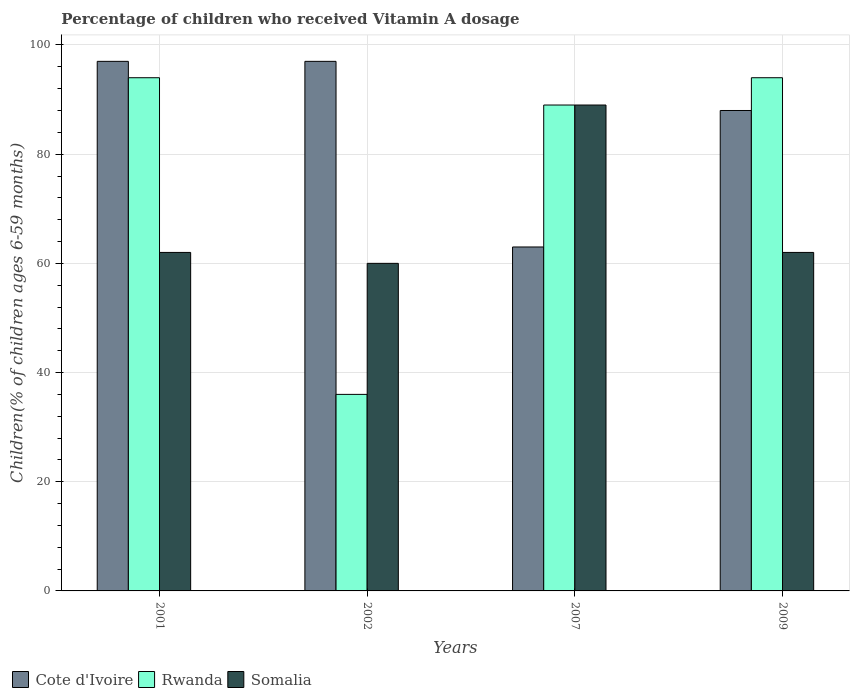How many different coloured bars are there?
Provide a short and direct response. 3. How many groups of bars are there?
Provide a short and direct response. 4. Are the number of bars per tick equal to the number of legend labels?
Offer a terse response. Yes. Are the number of bars on each tick of the X-axis equal?
Ensure brevity in your answer.  Yes. How many bars are there on the 2nd tick from the right?
Your answer should be very brief. 3. What is the label of the 1st group of bars from the left?
Provide a succinct answer. 2001. What is the percentage of children who received Vitamin A dosage in Cote d'Ivoire in 2001?
Offer a very short reply. 97. Across all years, what is the maximum percentage of children who received Vitamin A dosage in Rwanda?
Offer a very short reply. 94. In which year was the percentage of children who received Vitamin A dosage in Cote d'Ivoire minimum?
Give a very brief answer. 2007. What is the total percentage of children who received Vitamin A dosage in Rwanda in the graph?
Provide a succinct answer. 313. What is the difference between the percentage of children who received Vitamin A dosage in Cote d'Ivoire in 2007 and that in 2009?
Your answer should be very brief. -25. What is the difference between the percentage of children who received Vitamin A dosage in Cote d'Ivoire in 2001 and the percentage of children who received Vitamin A dosage in Somalia in 2002?
Your response must be concise. 37. What is the average percentage of children who received Vitamin A dosage in Cote d'Ivoire per year?
Ensure brevity in your answer.  86.25. In the year 2001, what is the difference between the percentage of children who received Vitamin A dosage in Somalia and percentage of children who received Vitamin A dosage in Cote d'Ivoire?
Your answer should be compact. -35. What is the ratio of the percentage of children who received Vitamin A dosage in Somalia in 2002 to that in 2007?
Your answer should be very brief. 0.67. Is the difference between the percentage of children who received Vitamin A dosage in Somalia in 2007 and 2009 greater than the difference between the percentage of children who received Vitamin A dosage in Cote d'Ivoire in 2007 and 2009?
Provide a succinct answer. Yes. What is the difference between the highest and the second highest percentage of children who received Vitamin A dosage in Cote d'Ivoire?
Provide a short and direct response. 0. Is the sum of the percentage of children who received Vitamin A dosage in Somalia in 2001 and 2002 greater than the maximum percentage of children who received Vitamin A dosage in Cote d'Ivoire across all years?
Keep it short and to the point. Yes. What does the 3rd bar from the left in 2009 represents?
Offer a very short reply. Somalia. What does the 1st bar from the right in 2007 represents?
Give a very brief answer. Somalia. Where does the legend appear in the graph?
Make the answer very short. Bottom left. How are the legend labels stacked?
Offer a very short reply. Horizontal. What is the title of the graph?
Make the answer very short. Percentage of children who received Vitamin A dosage. Does "Iraq" appear as one of the legend labels in the graph?
Your answer should be compact. No. What is the label or title of the Y-axis?
Offer a terse response. Children(% of children ages 6-59 months). What is the Children(% of children ages 6-59 months) of Cote d'Ivoire in 2001?
Offer a terse response. 97. What is the Children(% of children ages 6-59 months) of Rwanda in 2001?
Provide a short and direct response. 94. What is the Children(% of children ages 6-59 months) of Somalia in 2001?
Provide a short and direct response. 62. What is the Children(% of children ages 6-59 months) of Cote d'Ivoire in 2002?
Provide a succinct answer. 97. What is the Children(% of children ages 6-59 months) of Rwanda in 2002?
Keep it short and to the point. 36. What is the Children(% of children ages 6-59 months) of Rwanda in 2007?
Your response must be concise. 89. What is the Children(% of children ages 6-59 months) in Somalia in 2007?
Give a very brief answer. 89. What is the Children(% of children ages 6-59 months) in Rwanda in 2009?
Ensure brevity in your answer.  94. Across all years, what is the maximum Children(% of children ages 6-59 months) in Cote d'Ivoire?
Make the answer very short. 97. Across all years, what is the maximum Children(% of children ages 6-59 months) in Rwanda?
Your answer should be compact. 94. Across all years, what is the maximum Children(% of children ages 6-59 months) in Somalia?
Ensure brevity in your answer.  89. Across all years, what is the minimum Children(% of children ages 6-59 months) in Cote d'Ivoire?
Keep it short and to the point. 63. What is the total Children(% of children ages 6-59 months) in Cote d'Ivoire in the graph?
Provide a short and direct response. 345. What is the total Children(% of children ages 6-59 months) of Rwanda in the graph?
Your response must be concise. 313. What is the total Children(% of children ages 6-59 months) of Somalia in the graph?
Your answer should be compact. 273. What is the difference between the Children(% of children ages 6-59 months) in Cote d'Ivoire in 2001 and that in 2002?
Give a very brief answer. 0. What is the difference between the Children(% of children ages 6-59 months) in Cote d'Ivoire in 2001 and that in 2007?
Your answer should be very brief. 34. What is the difference between the Children(% of children ages 6-59 months) of Cote d'Ivoire in 2001 and that in 2009?
Offer a very short reply. 9. What is the difference between the Children(% of children ages 6-59 months) of Rwanda in 2001 and that in 2009?
Ensure brevity in your answer.  0. What is the difference between the Children(% of children ages 6-59 months) of Cote d'Ivoire in 2002 and that in 2007?
Offer a terse response. 34. What is the difference between the Children(% of children ages 6-59 months) in Rwanda in 2002 and that in 2007?
Ensure brevity in your answer.  -53. What is the difference between the Children(% of children ages 6-59 months) in Somalia in 2002 and that in 2007?
Make the answer very short. -29. What is the difference between the Children(% of children ages 6-59 months) of Cote d'Ivoire in 2002 and that in 2009?
Your response must be concise. 9. What is the difference between the Children(% of children ages 6-59 months) of Rwanda in 2002 and that in 2009?
Provide a succinct answer. -58. What is the difference between the Children(% of children ages 6-59 months) of Somalia in 2002 and that in 2009?
Keep it short and to the point. -2. What is the difference between the Children(% of children ages 6-59 months) in Rwanda in 2007 and that in 2009?
Make the answer very short. -5. What is the difference between the Children(% of children ages 6-59 months) of Cote d'Ivoire in 2001 and the Children(% of children ages 6-59 months) of Somalia in 2002?
Give a very brief answer. 37. What is the difference between the Children(% of children ages 6-59 months) in Rwanda in 2001 and the Children(% of children ages 6-59 months) in Somalia in 2002?
Your answer should be very brief. 34. What is the difference between the Children(% of children ages 6-59 months) of Cote d'Ivoire in 2001 and the Children(% of children ages 6-59 months) of Somalia in 2009?
Offer a very short reply. 35. What is the difference between the Children(% of children ages 6-59 months) of Rwanda in 2001 and the Children(% of children ages 6-59 months) of Somalia in 2009?
Your answer should be compact. 32. What is the difference between the Children(% of children ages 6-59 months) in Cote d'Ivoire in 2002 and the Children(% of children ages 6-59 months) in Rwanda in 2007?
Your answer should be compact. 8. What is the difference between the Children(% of children ages 6-59 months) of Rwanda in 2002 and the Children(% of children ages 6-59 months) of Somalia in 2007?
Your answer should be compact. -53. What is the difference between the Children(% of children ages 6-59 months) of Cote d'Ivoire in 2002 and the Children(% of children ages 6-59 months) of Rwanda in 2009?
Your answer should be very brief. 3. What is the difference between the Children(% of children ages 6-59 months) in Cote d'Ivoire in 2007 and the Children(% of children ages 6-59 months) in Rwanda in 2009?
Your answer should be very brief. -31. What is the difference between the Children(% of children ages 6-59 months) in Cote d'Ivoire in 2007 and the Children(% of children ages 6-59 months) in Somalia in 2009?
Give a very brief answer. 1. What is the difference between the Children(% of children ages 6-59 months) of Rwanda in 2007 and the Children(% of children ages 6-59 months) of Somalia in 2009?
Offer a terse response. 27. What is the average Children(% of children ages 6-59 months) in Cote d'Ivoire per year?
Your response must be concise. 86.25. What is the average Children(% of children ages 6-59 months) of Rwanda per year?
Your response must be concise. 78.25. What is the average Children(% of children ages 6-59 months) in Somalia per year?
Make the answer very short. 68.25. In the year 2001, what is the difference between the Children(% of children ages 6-59 months) in Cote d'Ivoire and Children(% of children ages 6-59 months) in Somalia?
Provide a short and direct response. 35. In the year 2002, what is the difference between the Children(% of children ages 6-59 months) in Cote d'Ivoire and Children(% of children ages 6-59 months) in Somalia?
Your answer should be compact. 37. In the year 2002, what is the difference between the Children(% of children ages 6-59 months) in Rwanda and Children(% of children ages 6-59 months) in Somalia?
Your answer should be compact. -24. In the year 2007, what is the difference between the Children(% of children ages 6-59 months) of Rwanda and Children(% of children ages 6-59 months) of Somalia?
Offer a very short reply. 0. In the year 2009, what is the difference between the Children(% of children ages 6-59 months) of Cote d'Ivoire and Children(% of children ages 6-59 months) of Somalia?
Make the answer very short. 26. What is the ratio of the Children(% of children ages 6-59 months) of Cote d'Ivoire in 2001 to that in 2002?
Keep it short and to the point. 1. What is the ratio of the Children(% of children ages 6-59 months) in Rwanda in 2001 to that in 2002?
Offer a very short reply. 2.61. What is the ratio of the Children(% of children ages 6-59 months) in Somalia in 2001 to that in 2002?
Make the answer very short. 1.03. What is the ratio of the Children(% of children ages 6-59 months) of Cote d'Ivoire in 2001 to that in 2007?
Provide a short and direct response. 1.54. What is the ratio of the Children(% of children ages 6-59 months) in Rwanda in 2001 to that in 2007?
Provide a short and direct response. 1.06. What is the ratio of the Children(% of children ages 6-59 months) of Somalia in 2001 to that in 2007?
Give a very brief answer. 0.7. What is the ratio of the Children(% of children ages 6-59 months) of Cote d'Ivoire in 2001 to that in 2009?
Provide a short and direct response. 1.1. What is the ratio of the Children(% of children ages 6-59 months) of Somalia in 2001 to that in 2009?
Make the answer very short. 1. What is the ratio of the Children(% of children ages 6-59 months) in Cote d'Ivoire in 2002 to that in 2007?
Offer a very short reply. 1.54. What is the ratio of the Children(% of children ages 6-59 months) in Rwanda in 2002 to that in 2007?
Your response must be concise. 0.4. What is the ratio of the Children(% of children ages 6-59 months) in Somalia in 2002 to that in 2007?
Provide a succinct answer. 0.67. What is the ratio of the Children(% of children ages 6-59 months) of Cote d'Ivoire in 2002 to that in 2009?
Provide a short and direct response. 1.1. What is the ratio of the Children(% of children ages 6-59 months) of Rwanda in 2002 to that in 2009?
Your answer should be very brief. 0.38. What is the ratio of the Children(% of children ages 6-59 months) in Somalia in 2002 to that in 2009?
Your response must be concise. 0.97. What is the ratio of the Children(% of children ages 6-59 months) in Cote d'Ivoire in 2007 to that in 2009?
Provide a short and direct response. 0.72. What is the ratio of the Children(% of children ages 6-59 months) in Rwanda in 2007 to that in 2009?
Your answer should be very brief. 0.95. What is the ratio of the Children(% of children ages 6-59 months) in Somalia in 2007 to that in 2009?
Offer a very short reply. 1.44. What is the difference between the highest and the second highest Children(% of children ages 6-59 months) of Cote d'Ivoire?
Offer a terse response. 0. What is the difference between the highest and the second highest Children(% of children ages 6-59 months) in Somalia?
Offer a terse response. 27. What is the difference between the highest and the lowest Children(% of children ages 6-59 months) of Somalia?
Offer a very short reply. 29. 